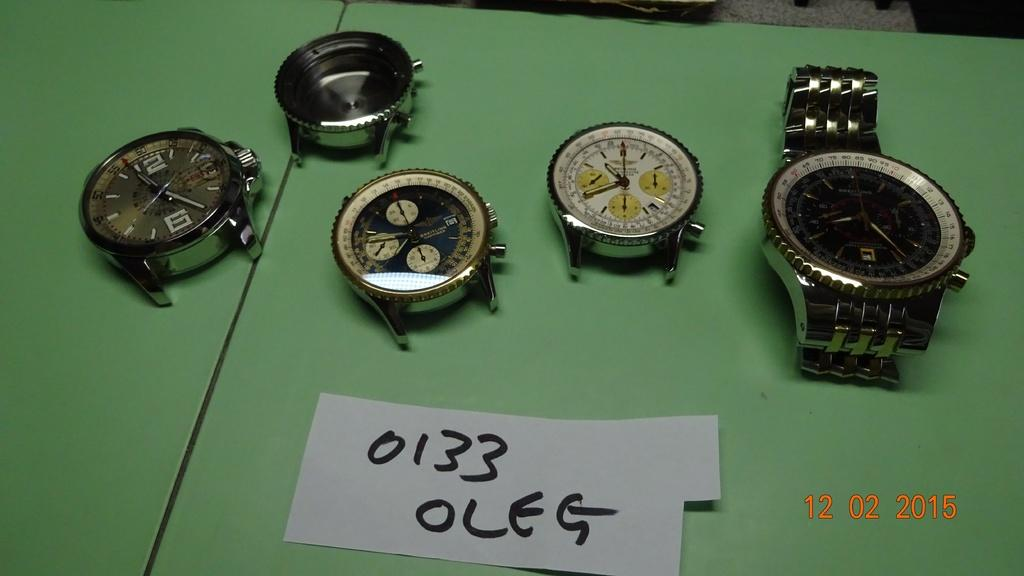<image>
Share a concise interpretation of the image provided. several watch pieces are laying on a green table with a paper saying 0133 OLEG 